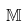Convert formula to latex. <formula><loc_0><loc_0><loc_500><loc_500>\mathbb { M }</formula> 